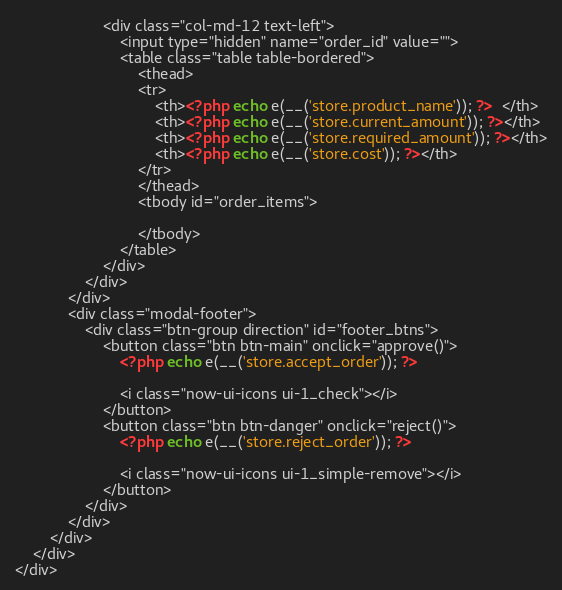Convert code to text. <code><loc_0><loc_0><loc_500><loc_500><_PHP_>                    <div class="col-md-12 text-left">
                        <input type="hidden" name="order_id" value="">
                        <table class="table table-bordered">
                            <thead>
                            <tr>
                                <th><?php echo e(__('store.product_name')); ?>  </th>
                                <th><?php echo e(__('store.current_amount')); ?></th>
                                <th><?php echo e(__('store.required_amount')); ?></th>
                                <th><?php echo e(__('store.cost')); ?></th>
                            </tr>
                            </thead>
                            <tbody id="order_items">

                            </tbody>
                        </table>
                    </div>
                </div>
            </div>
            <div class="modal-footer">
                <div class="btn-group direction" id="footer_btns">
                    <button class="btn btn-main" onclick="approve()">
                        <?php echo e(__('store.accept_order')); ?>

                        <i class="now-ui-icons ui-1_check"></i>
                    </button>
                    <button class="btn btn-danger" onclick="reject()">
                        <?php echo e(__('store.reject_order')); ?>

                        <i class="now-ui-icons ui-1_simple-remove"></i>
                    </button>
                </div>
            </div>
        </div>
    </div>
</div>
</code> 